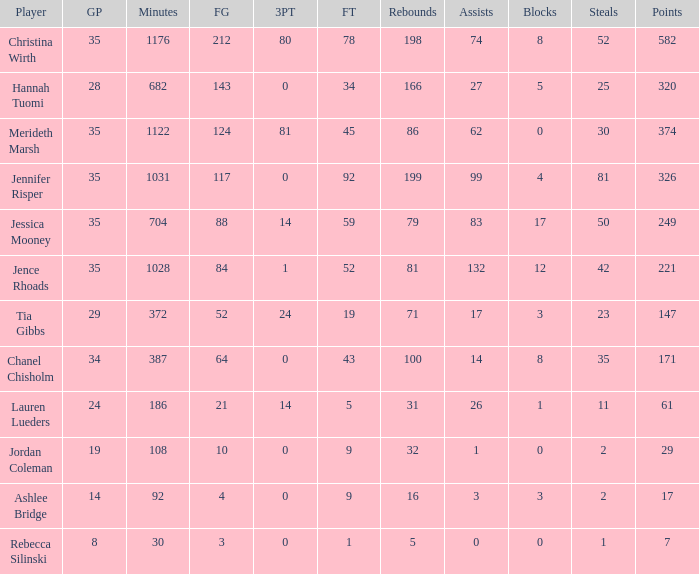How many blockings occured in the game with 198 rebounds? 8.0. Help me parse the entirety of this table. {'header': ['Player', 'GP', 'Minutes', 'FG', '3PT', 'FT', 'Rebounds', 'Assists', 'Blocks', 'Steals', 'Points'], 'rows': [['Christina Wirth', '35', '1176', '212', '80', '78', '198', '74', '8', '52', '582'], ['Hannah Tuomi', '28', '682', '143', '0', '34', '166', '27', '5', '25', '320'], ['Merideth Marsh', '35', '1122', '124', '81', '45', '86', '62', '0', '30', '374'], ['Jennifer Risper', '35', '1031', '117', '0', '92', '199', '99', '4', '81', '326'], ['Jessica Mooney', '35', '704', '88', '14', '59', '79', '83', '17', '50', '249'], ['Jence Rhoads', '35', '1028', '84', '1', '52', '81', '132', '12', '42', '221'], ['Tia Gibbs', '29', '372', '52', '24', '19', '71', '17', '3', '23', '147'], ['Chanel Chisholm', '34', '387', '64', '0', '43', '100', '14', '8', '35', '171'], ['Lauren Lueders', '24', '186', '21', '14', '5', '31', '26', '1', '11', '61'], ['Jordan Coleman', '19', '108', '10', '0', '9', '32', '1', '0', '2', '29'], ['Ashlee Bridge', '14', '92', '4', '0', '9', '16', '3', '3', '2', '17'], ['Rebecca Silinski', '8', '30', '3', '0', '1', '5', '0', '0', '1', '7']]} 